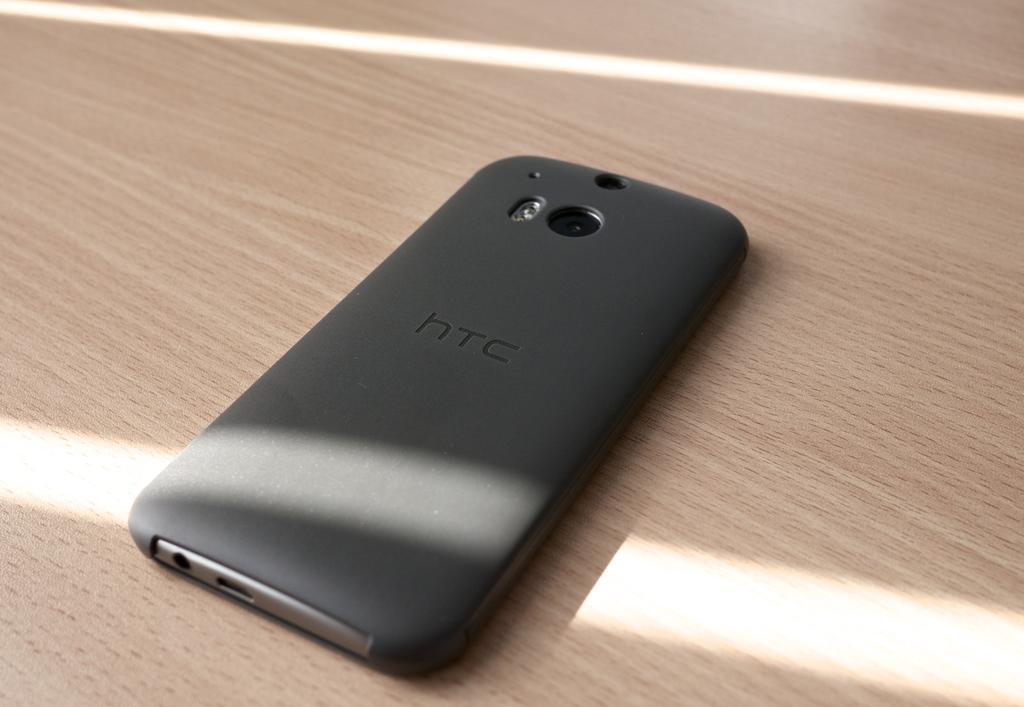<image>
Describe the image concisely. A phone face down on a table with the letters HTC halfway down 